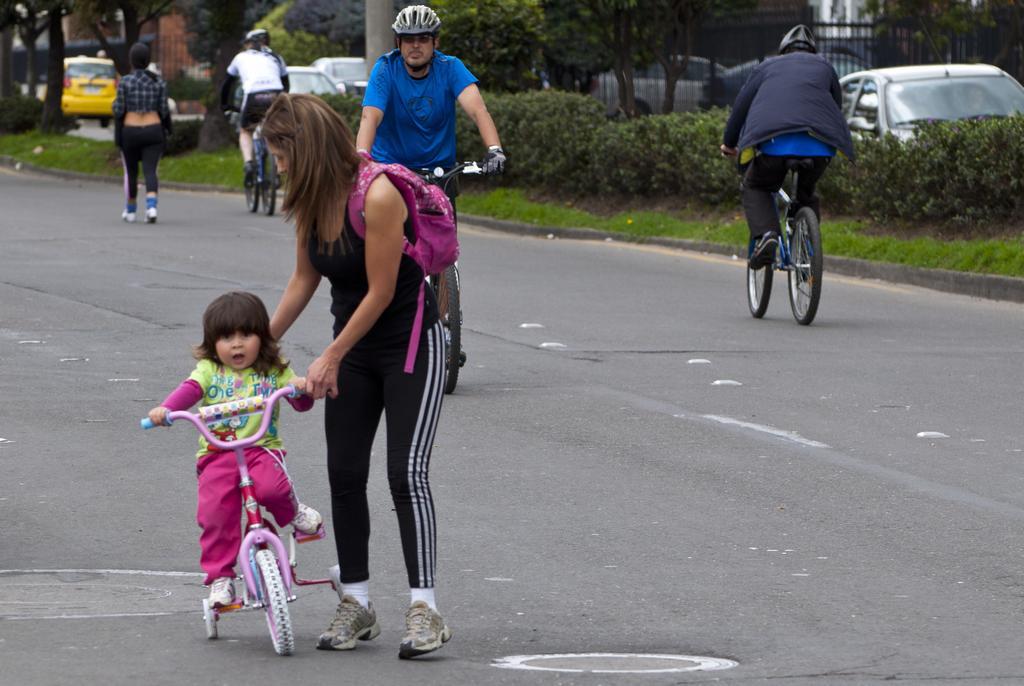How would you summarize this image in a sentence or two? In this image, we can see a woman standing and holding a small bicycle, there is a girl sitting on a bicycle. We can see two persons riding bicycles. There are some cars on the road and we can see some plants and trees. There is a fencing. 